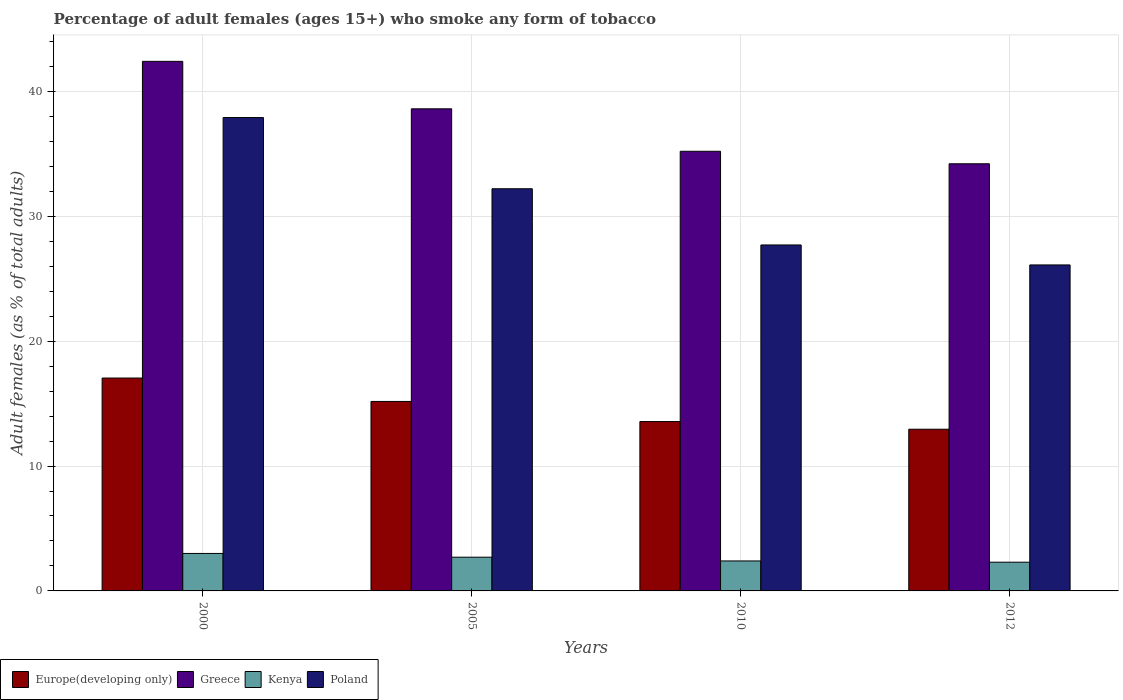Are the number of bars per tick equal to the number of legend labels?
Make the answer very short. Yes. Are the number of bars on each tick of the X-axis equal?
Make the answer very short. Yes. How many bars are there on the 3rd tick from the left?
Provide a succinct answer. 4. How many bars are there on the 2nd tick from the right?
Your answer should be compact. 4. In how many cases, is the number of bars for a given year not equal to the number of legend labels?
Ensure brevity in your answer.  0. What is the percentage of adult females who smoke in Greece in 2005?
Ensure brevity in your answer.  38.6. Across all years, what is the minimum percentage of adult females who smoke in Poland?
Ensure brevity in your answer.  26.1. In which year was the percentage of adult females who smoke in Europe(developing only) maximum?
Give a very brief answer. 2000. What is the total percentage of adult females who smoke in Europe(developing only) in the graph?
Ensure brevity in your answer.  58.72. What is the difference between the percentage of adult females who smoke in Greece in 2000 and that in 2010?
Your answer should be very brief. 7.2. What is the difference between the percentage of adult females who smoke in Poland in 2010 and the percentage of adult females who smoke in Europe(developing only) in 2012?
Provide a succinct answer. 14.75. What is the average percentage of adult females who smoke in Greece per year?
Ensure brevity in your answer.  37.6. In the year 2000, what is the difference between the percentage of adult females who smoke in Greece and percentage of adult females who smoke in Europe(developing only)?
Keep it short and to the point. 25.36. What is the ratio of the percentage of adult females who smoke in Greece in 2005 to that in 2012?
Your response must be concise. 1.13. Is the percentage of adult females who smoke in Kenya in 2000 less than that in 2012?
Provide a succinct answer. No. Is the difference between the percentage of adult females who smoke in Greece in 2005 and 2012 greater than the difference between the percentage of adult females who smoke in Europe(developing only) in 2005 and 2012?
Make the answer very short. Yes. What is the difference between the highest and the second highest percentage of adult females who smoke in Kenya?
Your answer should be very brief. 0.3. What is the difference between the highest and the lowest percentage of adult females who smoke in Kenya?
Make the answer very short. 0.7. Is the sum of the percentage of adult females who smoke in Greece in 2000 and 2005 greater than the maximum percentage of adult females who smoke in Poland across all years?
Provide a succinct answer. Yes. Is it the case that in every year, the sum of the percentage of adult females who smoke in Europe(developing only) and percentage of adult females who smoke in Poland is greater than the sum of percentage of adult females who smoke in Kenya and percentage of adult females who smoke in Greece?
Offer a terse response. Yes. What does the 2nd bar from the right in 2010 represents?
Offer a very short reply. Kenya. Is it the case that in every year, the sum of the percentage of adult females who smoke in Kenya and percentage of adult females who smoke in Greece is greater than the percentage of adult females who smoke in Europe(developing only)?
Ensure brevity in your answer.  Yes. What is the difference between two consecutive major ticks on the Y-axis?
Your response must be concise. 10. Does the graph contain any zero values?
Keep it short and to the point. No. Where does the legend appear in the graph?
Your answer should be compact. Bottom left. What is the title of the graph?
Offer a terse response. Percentage of adult females (ages 15+) who smoke any form of tobacco. What is the label or title of the Y-axis?
Make the answer very short. Adult females (as % of total adults). What is the Adult females (as % of total adults) of Europe(developing only) in 2000?
Your answer should be very brief. 17.04. What is the Adult females (as % of total adults) in Greece in 2000?
Offer a very short reply. 42.4. What is the Adult females (as % of total adults) in Poland in 2000?
Provide a succinct answer. 37.9. What is the Adult females (as % of total adults) in Europe(developing only) in 2005?
Provide a succinct answer. 15.17. What is the Adult females (as % of total adults) in Greece in 2005?
Ensure brevity in your answer.  38.6. What is the Adult females (as % of total adults) of Poland in 2005?
Provide a short and direct response. 32.2. What is the Adult females (as % of total adults) in Europe(developing only) in 2010?
Offer a very short reply. 13.56. What is the Adult females (as % of total adults) in Greece in 2010?
Your response must be concise. 35.2. What is the Adult females (as % of total adults) of Poland in 2010?
Provide a succinct answer. 27.7. What is the Adult females (as % of total adults) in Europe(developing only) in 2012?
Provide a succinct answer. 12.95. What is the Adult females (as % of total adults) of Greece in 2012?
Offer a very short reply. 34.2. What is the Adult females (as % of total adults) in Kenya in 2012?
Ensure brevity in your answer.  2.3. What is the Adult females (as % of total adults) of Poland in 2012?
Ensure brevity in your answer.  26.1. Across all years, what is the maximum Adult females (as % of total adults) of Europe(developing only)?
Ensure brevity in your answer.  17.04. Across all years, what is the maximum Adult females (as % of total adults) of Greece?
Offer a terse response. 42.4. Across all years, what is the maximum Adult females (as % of total adults) in Poland?
Your answer should be very brief. 37.9. Across all years, what is the minimum Adult females (as % of total adults) in Europe(developing only)?
Make the answer very short. 12.95. Across all years, what is the minimum Adult females (as % of total adults) of Greece?
Offer a terse response. 34.2. Across all years, what is the minimum Adult females (as % of total adults) of Poland?
Offer a terse response. 26.1. What is the total Adult females (as % of total adults) in Europe(developing only) in the graph?
Offer a terse response. 58.72. What is the total Adult females (as % of total adults) in Greece in the graph?
Your response must be concise. 150.4. What is the total Adult females (as % of total adults) of Kenya in the graph?
Your response must be concise. 10.4. What is the total Adult females (as % of total adults) of Poland in the graph?
Your answer should be compact. 123.9. What is the difference between the Adult females (as % of total adults) of Europe(developing only) in 2000 and that in 2005?
Provide a short and direct response. 1.87. What is the difference between the Adult females (as % of total adults) in Greece in 2000 and that in 2005?
Offer a very short reply. 3.8. What is the difference between the Adult females (as % of total adults) in Kenya in 2000 and that in 2005?
Provide a succinct answer. 0.3. What is the difference between the Adult females (as % of total adults) of Poland in 2000 and that in 2005?
Your answer should be very brief. 5.7. What is the difference between the Adult females (as % of total adults) of Europe(developing only) in 2000 and that in 2010?
Give a very brief answer. 3.48. What is the difference between the Adult females (as % of total adults) of Europe(developing only) in 2000 and that in 2012?
Make the answer very short. 4.1. What is the difference between the Adult females (as % of total adults) of Poland in 2000 and that in 2012?
Keep it short and to the point. 11.8. What is the difference between the Adult females (as % of total adults) of Europe(developing only) in 2005 and that in 2010?
Your answer should be very brief. 1.61. What is the difference between the Adult females (as % of total adults) of Greece in 2005 and that in 2010?
Provide a short and direct response. 3.4. What is the difference between the Adult females (as % of total adults) of Poland in 2005 and that in 2010?
Your answer should be compact. 4.5. What is the difference between the Adult females (as % of total adults) of Europe(developing only) in 2005 and that in 2012?
Your response must be concise. 2.22. What is the difference between the Adult females (as % of total adults) in Greece in 2005 and that in 2012?
Your response must be concise. 4.4. What is the difference between the Adult females (as % of total adults) in Kenya in 2005 and that in 2012?
Make the answer very short. 0.4. What is the difference between the Adult females (as % of total adults) in Poland in 2005 and that in 2012?
Provide a short and direct response. 6.1. What is the difference between the Adult females (as % of total adults) in Europe(developing only) in 2010 and that in 2012?
Give a very brief answer. 0.61. What is the difference between the Adult females (as % of total adults) in Greece in 2010 and that in 2012?
Provide a short and direct response. 1. What is the difference between the Adult females (as % of total adults) in Kenya in 2010 and that in 2012?
Make the answer very short. 0.1. What is the difference between the Adult females (as % of total adults) in Europe(developing only) in 2000 and the Adult females (as % of total adults) in Greece in 2005?
Provide a short and direct response. -21.56. What is the difference between the Adult females (as % of total adults) in Europe(developing only) in 2000 and the Adult females (as % of total adults) in Kenya in 2005?
Ensure brevity in your answer.  14.34. What is the difference between the Adult females (as % of total adults) of Europe(developing only) in 2000 and the Adult females (as % of total adults) of Poland in 2005?
Your answer should be very brief. -15.16. What is the difference between the Adult females (as % of total adults) in Greece in 2000 and the Adult females (as % of total adults) in Kenya in 2005?
Make the answer very short. 39.7. What is the difference between the Adult females (as % of total adults) in Greece in 2000 and the Adult females (as % of total adults) in Poland in 2005?
Offer a very short reply. 10.2. What is the difference between the Adult females (as % of total adults) in Kenya in 2000 and the Adult females (as % of total adults) in Poland in 2005?
Give a very brief answer. -29.2. What is the difference between the Adult females (as % of total adults) in Europe(developing only) in 2000 and the Adult females (as % of total adults) in Greece in 2010?
Make the answer very short. -18.16. What is the difference between the Adult females (as % of total adults) of Europe(developing only) in 2000 and the Adult females (as % of total adults) of Kenya in 2010?
Make the answer very short. 14.64. What is the difference between the Adult females (as % of total adults) of Europe(developing only) in 2000 and the Adult females (as % of total adults) of Poland in 2010?
Your answer should be compact. -10.66. What is the difference between the Adult females (as % of total adults) of Greece in 2000 and the Adult females (as % of total adults) of Kenya in 2010?
Offer a terse response. 40. What is the difference between the Adult females (as % of total adults) in Greece in 2000 and the Adult females (as % of total adults) in Poland in 2010?
Provide a succinct answer. 14.7. What is the difference between the Adult females (as % of total adults) in Kenya in 2000 and the Adult females (as % of total adults) in Poland in 2010?
Offer a very short reply. -24.7. What is the difference between the Adult females (as % of total adults) of Europe(developing only) in 2000 and the Adult females (as % of total adults) of Greece in 2012?
Give a very brief answer. -17.16. What is the difference between the Adult females (as % of total adults) of Europe(developing only) in 2000 and the Adult females (as % of total adults) of Kenya in 2012?
Your answer should be very brief. 14.74. What is the difference between the Adult females (as % of total adults) in Europe(developing only) in 2000 and the Adult females (as % of total adults) in Poland in 2012?
Your answer should be very brief. -9.06. What is the difference between the Adult females (as % of total adults) of Greece in 2000 and the Adult females (as % of total adults) of Kenya in 2012?
Give a very brief answer. 40.1. What is the difference between the Adult females (as % of total adults) of Kenya in 2000 and the Adult females (as % of total adults) of Poland in 2012?
Keep it short and to the point. -23.1. What is the difference between the Adult females (as % of total adults) in Europe(developing only) in 2005 and the Adult females (as % of total adults) in Greece in 2010?
Your answer should be very brief. -20.03. What is the difference between the Adult females (as % of total adults) in Europe(developing only) in 2005 and the Adult females (as % of total adults) in Kenya in 2010?
Make the answer very short. 12.77. What is the difference between the Adult females (as % of total adults) of Europe(developing only) in 2005 and the Adult females (as % of total adults) of Poland in 2010?
Your answer should be compact. -12.53. What is the difference between the Adult females (as % of total adults) of Greece in 2005 and the Adult females (as % of total adults) of Kenya in 2010?
Make the answer very short. 36.2. What is the difference between the Adult females (as % of total adults) of Kenya in 2005 and the Adult females (as % of total adults) of Poland in 2010?
Keep it short and to the point. -25. What is the difference between the Adult females (as % of total adults) of Europe(developing only) in 2005 and the Adult females (as % of total adults) of Greece in 2012?
Ensure brevity in your answer.  -19.03. What is the difference between the Adult females (as % of total adults) in Europe(developing only) in 2005 and the Adult females (as % of total adults) in Kenya in 2012?
Make the answer very short. 12.87. What is the difference between the Adult females (as % of total adults) in Europe(developing only) in 2005 and the Adult females (as % of total adults) in Poland in 2012?
Offer a terse response. -10.93. What is the difference between the Adult females (as % of total adults) of Greece in 2005 and the Adult females (as % of total adults) of Kenya in 2012?
Your answer should be very brief. 36.3. What is the difference between the Adult females (as % of total adults) of Greece in 2005 and the Adult females (as % of total adults) of Poland in 2012?
Provide a succinct answer. 12.5. What is the difference between the Adult females (as % of total adults) of Kenya in 2005 and the Adult females (as % of total adults) of Poland in 2012?
Ensure brevity in your answer.  -23.4. What is the difference between the Adult females (as % of total adults) of Europe(developing only) in 2010 and the Adult females (as % of total adults) of Greece in 2012?
Offer a very short reply. -20.64. What is the difference between the Adult females (as % of total adults) of Europe(developing only) in 2010 and the Adult females (as % of total adults) of Kenya in 2012?
Ensure brevity in your answer.  11.26. What is the difference between the Adult females (as % of total adults) in Europe(developing only) in 2010 and the Adult females (as % of total adults) in Poland in 2012?
Your response must be concise. -12.54. What is the difference between the Adult females (as % of total adults) in Greece in 2010 and the Adult females (as % of total adults) in Kenya in 2012?
Offer a very short reply. 32.9. What is the difference between the Adult females (as % of total adults) in Kenya in 2010 and the Adult females (as % of total adults) in Poland in 2012?
Your answer should be compact. -23.7. What is the average Adult females (as % of total adults) of Europe(developing only) per year?
Give a very brief answer. 14.68. What is the average Adult females (as % of total adults) in Greece per year?
Provide a short and direct response. 37.6. What is the average Adult females (as % of total adults) of Kenya per year?
Offer a very short reply. 2.6. What is the average Adult females (as % of total adults) in Poland per year?
Offer a terse response. 30.98. In the year 2000, what is the difference between the Adult females (as % of total adults) of Europe(developing only) and Adult females (as % of total adults) of Greece?
Make the answer very short. -25.36. In the year 2000, what is the difference between the Adult females (as % of total adults) of Europe(developing only) and Adult females (as % of total adults) of Kenya?
Offer a very short reply. 14.04. In the year 2000, what is the difference between the Adult females (as % of total adults) in Europe(developing only) and Adult females (as % of total adults) in Poland?
Give a very brief answer. -20.86. In the year 2000, what is the difference between the Adult females (as % of total adults) in Greece and Adult females (as % of total adults) in Kenya?
Offer a terse response. 39.4. In the year 2000, what is the difference between the Adult females (as % of total adults) in Greece and Adult females (as % of total adults) in Poland?
Your response must be concise. 4.5. In the year 2000, what is the difference between the Adult females (as % of total adults) in Kenya and Adult females (as % of total adults) in Poland?
Your answer should be compact. -34.9. In the year 2005, what is the difference between the Adult females (as % of total adults) of Europe(developing only) and Adult females (as % of total adults) of Greece?
Make the answer very short. -23.43. In the year 2005, what is the difference between the Adult females (as % of total adults) of Europe(developing only) and Adult females (as % of total adults) of Kenya?
Your answer should be very brief. 12.47. In the year 2005, what is the difference between the Adult females (as % of total adults) of Europe(developing only) and Adult females (as % of total adults) of Poland?
Provide a succinct answer. -17.03. In the year 2005, what is the difference between the Adult females (as % of total adults) of Greece and Adult females (as % of total adults) of Kenya?
Offer a terse response. 35.9. In the year 2005, what is the difference between the Adult females (as % of total adults) of Greece and Adult females (as % of total adults) of Poland?
Your response must be concise. 6.4. In the year 2005, what is the difference between the Adult females (as % of total adults) of Kenya and Adult females (as % of total adults) of Poland?
Keep it short and to the point. -29.5. In the year 2010, what is the difference between the Adult females (as % of total adults) of Europe(developing only) and Adult females (as % of total adults) of Greece?
Your response must be concise. -21.64. In the year 2010, what is the difference between the Adult females (as % of total adults) in Europe(developing only) and Adult females (as % of total adults) in Kenya?
Offer a terse response. 11.16. In the year 2010, what is the difference between the Adult females (as % of total adults) of Europe(developing only) and Adult females (as % of total adults) of Poland?
Provide a succinct answer. -14.14. In the year 2010, what is the difference between the Adult females (as % of total adults) of Greece and Adult females (as % of total adults) of Kenya?
Offer a very short reply. 32.8. In the year 2010, what is the difference between the Adult females (as % of total adults) in Kenya and Adult females (as % of total adults) in Poland?
Provide a succinct answer. -25.3. In the year 2012, what is the difference between the Adult females (as % of total adults) in Europe(developing only) and Adult females (as % of total adults) in Greece?
Your answer should be very brief. -21.25. In the year 2012, what is the difference between the Adult females (as % of total adults) of Europe(developing only) and Adult females (as % of total adults) of Kenya?
Offer a terse response. 10.65. In the year 2012, what is the difference between the Adult females (as % of total adults) in Europe(developing only) and Adult females (as % of total adults) in Poland?
Your answer should be very brief. -13.15. In the year 2012, what is the difference between the Adult females (as % of total adults) of Greece and Adult females (as % of total adults) of Kenya?
Give a very brief answer. 31.9. In the year 2012, what is the difference between the Adult females (as % of total adults) in Kenya and Adult females (as % of total adults) in Poland?
Offer a terse response. -23.8. What is the ratio of the Adult females (as % of total adults) in Europe(developing only) in 2000 to that in 2005?
Provide a succinct answer. 1.12. What is the ratio of the Adult females (as % of total adults) in Greece in 2000 to that in 2005?
Ensure brevity in your answer.  1.1. What is the ratio of the Adult females (as % of total adults) in Poland in 2000 to that in 2005?
Ensure brevity in your answer.  1.18. What is the ratio of the Adult females (as % of total adults) of Europe(developing only) in 2000 to that in 2010?
Provide a succinct answer. 1.26. What is the ratio of the Adult females (as % of total adults) of Greece in 2000 to that in 2010?
Your answer should be compact. 1.2. What is the ratio of the Adult females (as % of total adults) in Poland in 2000 to that in 2010?
Give a very brief answer. 1.37. What is the ratio of the Adult females (as % of total adults) in Europe(developing only) in 2000 to that in 2012?
Provide a succinct answer. 1.32. What is the ratio of the Adult females (as % of total adults) in Greece in 2000 to that in 2012?
Ensure brevity in your answer.  1.24. What is the ratio of the Adult females (as % of total adults) in Kenya in 2000 to that in 2012?
Offer a very short reply. 1.3. What is the ratio of the Adult females (as % of total adults) of Poland in 2000 to that in 2012?
Give a very brief answer. 1.45. What is the ratio of the Adult females (as % of total adults) in Europe(developing only) in 2005 to that in 2010?
Provide a short and direct response. 1.12. What is the ratio of the Adult females (as % of total adults) of Greece in 2005 to that in 2010?
Provide a succinct answer. 1.1. What is the ratio of the Adult females (as % of total adults) in Kenya in 2005 to that in 2010?
Provide a short and direct response. 1.12. What is the ratio of the Adult females (as % of total adults) of Poland in 2005 to that in 2010?
Your answer should be compact. 1.16. What is the ratio of the Adult females (as % of total adults) in Europe(developing only) in 2005 to that in 2012?
Give a very brief answer. 1.17. What is the ratio of the Adult females (as % of total adults) of Greece in 2005 to that in 2012?
Keep it short and to the point. 1.13. What is the ratio of the Adult females (as % of total adults) of Kenya in 2005 to that in 2012?
Offer a very short reply. 1.17. What is the ratio of the Adult females (as % of total adults) of Poland in 2005 to that in 2012?
Your response must be concise. 1.23. What is the ratio of the Adult females (as % of total adults) in Europe(developing only) in 2010 to that in 2012?
Your answer should be compact. 1.05. What is the ratio of the Adult females (as % of total adults) in Greece in 2010 to that in 2012?
Give a very brief answer. 1.03. What is the ratio of the Adult females (as % of total adults) in Kenya in 2010 to that in 2012?
Keep it short and to the point. 1.04. What is the ratio of the Adult females (as % of total adults) in Poland in 2010 to that in 2012?
Give a very brief answer. 1.06. What is the difference between the highest and the second highest Adult females (as % of total adults) in Europe(developing only)?
Your response must be concise. 1.87. What is the difference between the highest and the second highest Adult females (as % of total adults) of Greece?
Your answer should be compact. 3.8. What is the difference between the highest and the second highest Adult females (as % of total adults) in Poland?
Keep it short and to the point. 5.7. What is the difference between the highest and the lowest Adult females (as % of total adults) in Europe(developing only)?
Offer a terse response. 4.1. What is the difference between the highest and the lowest Adult females (as % of total adults) of Kenya?
Give a very brief answer. 0.7. 